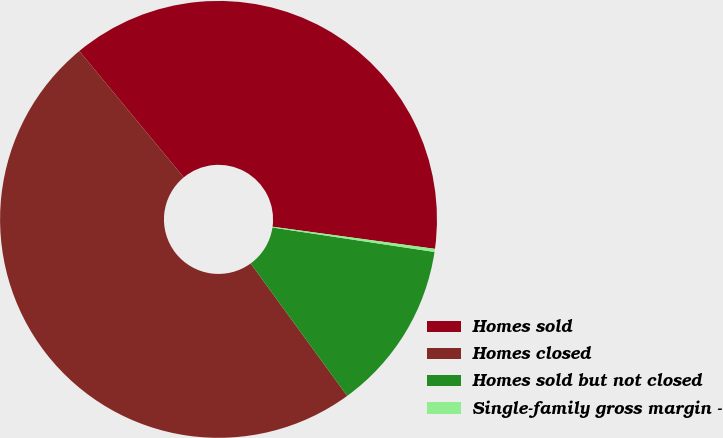Convert chart. <chart><loc_0><loc_0><loc_500><loc_500><pie_chart><fcel>Homes sold<fcel>Homes closed<fcel>Homes sold but not closed<fcel>Single-family gross margin -<nl><fcel>38.15%<fcel>49.03%<fcel>12.59%<fcel>0.23%<nl></chart> 